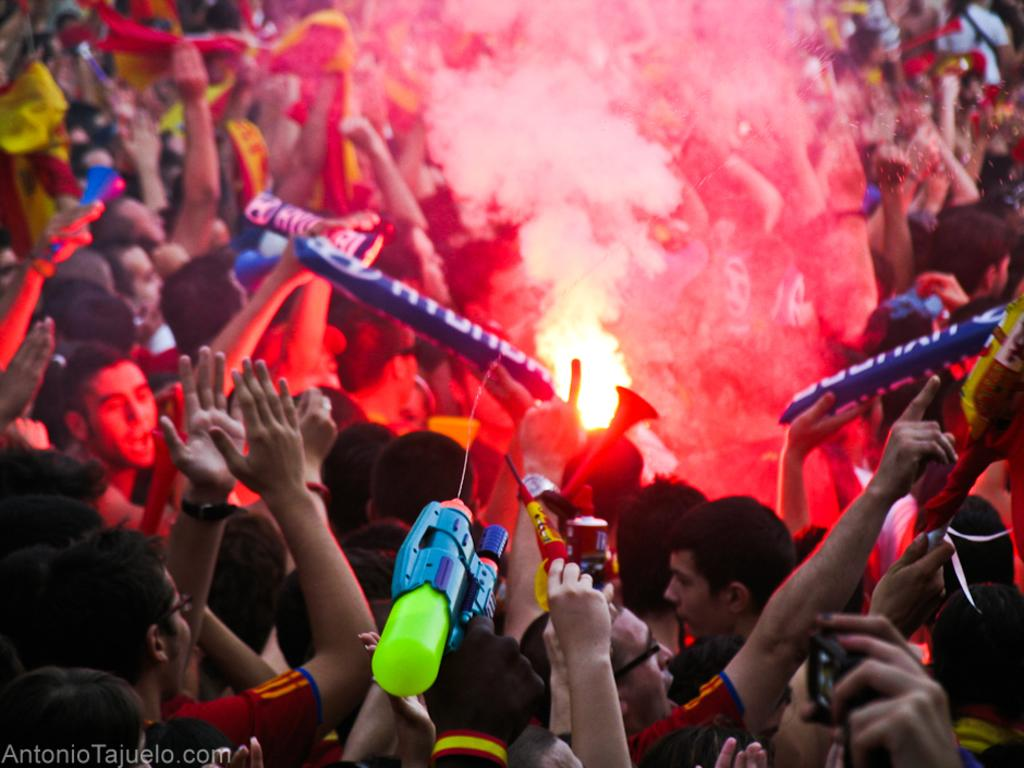Who or what can be seen in the image? There are people in the image. What are some of the people holding? Some people are holding inflatable objects. What else is visible in the image? There is smoke visible in the image. How would you describe the background of the image? The background of the image is blurry. How many cats are being distributed among the people in the image? There are no cats present in the image. What type of journey are the people taking in the image? There is no indication of a journey in the image; it simply shows people holding inflatable objects and smoke in the background. 